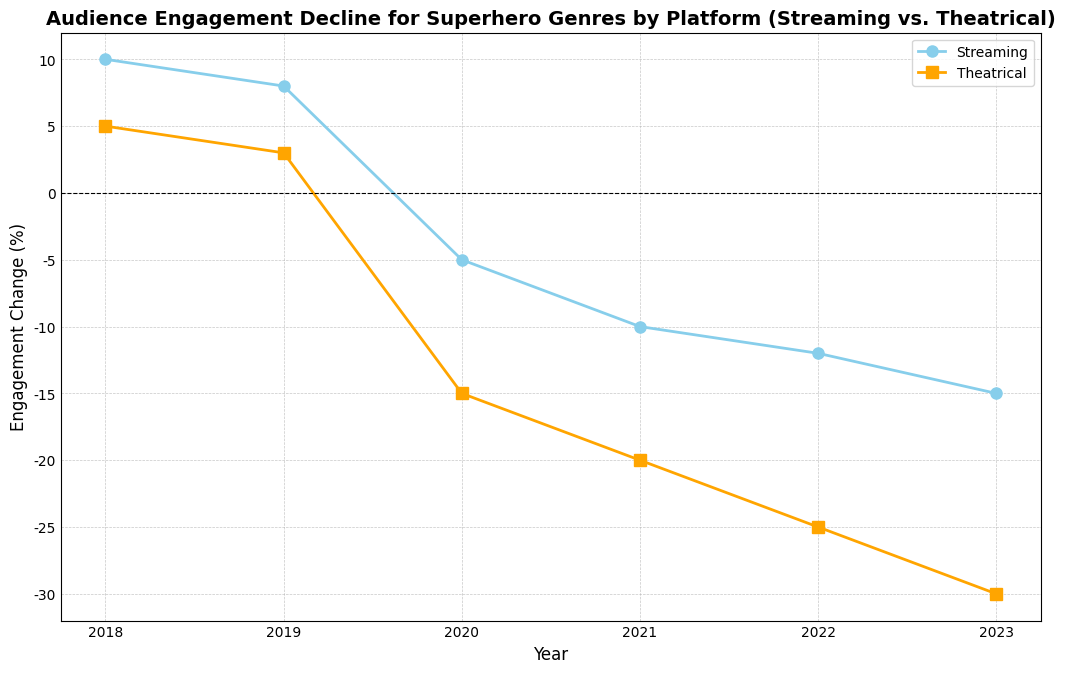What year did both platforms experience a positive audience engagement change? From the chart, we see that any year above the horizontal line (y=0) indicates a positive engagement change. Both platforms are above this line in 2018 and 2019.
Answer: 2018, 2019 Which platform had the greater negative engagement change in 2021? From the plot, compare the points for both platforms in 2021. Theatrical engagement change is at -20 while streaming is at -10.
Answer: Theatrical What's the average engagement change for the Streaming platform from 2020 to 2023? Calculate the average of the values from 2020 to 2023 for the Streaming platform: (-5 + -10 + -12 + -15) / 4 = -10.5
Answer: -10.5 In which years did the Theatrical platform decline more in engagement compared to Streaming? Identify the years where the orange line (Theatrical) is lower than the blue line (Streaming) in the negative direction: 2020, 2021, 2022, 2023.
Answer: 2020, 2021, 2022, 2023 What is the total engagement decline for the Theatrical platform over the period 2020-2023? Sum the engagement changes for Theatrical from 2020 to 2023: -15 + -20 + -25 + -30 = -90
Answer: -90 From 2018 to 2020, which platform's engagement declined more? Calculate the difference from 2018 to 2020 for each platform: Streaming (10 - (-5) = 15), Theatrical (5 - (-15) = 20). Theatrical declined more by 20 points.
Answer: Theatrical Which year shows the steepest decline in audience engagement for Streaming? Identify the year with the largest drop in Streaming from one year to the next. The drop from 2019 to 2020 is the steepest, with a change from 8 to -5, a drop of 13 points.
Answer: 2020 Which year had the smallest difference in engagement change between the two platforms? Calculate the absolute differences for each year and identify the smallest: 2018 (5), 2019 (5), 2020 (10), 2021 (10), 2022 (13), 2023 (15). The smallest difference is 5, both in 2018 and 2019.
Answer: 2018, 2019 